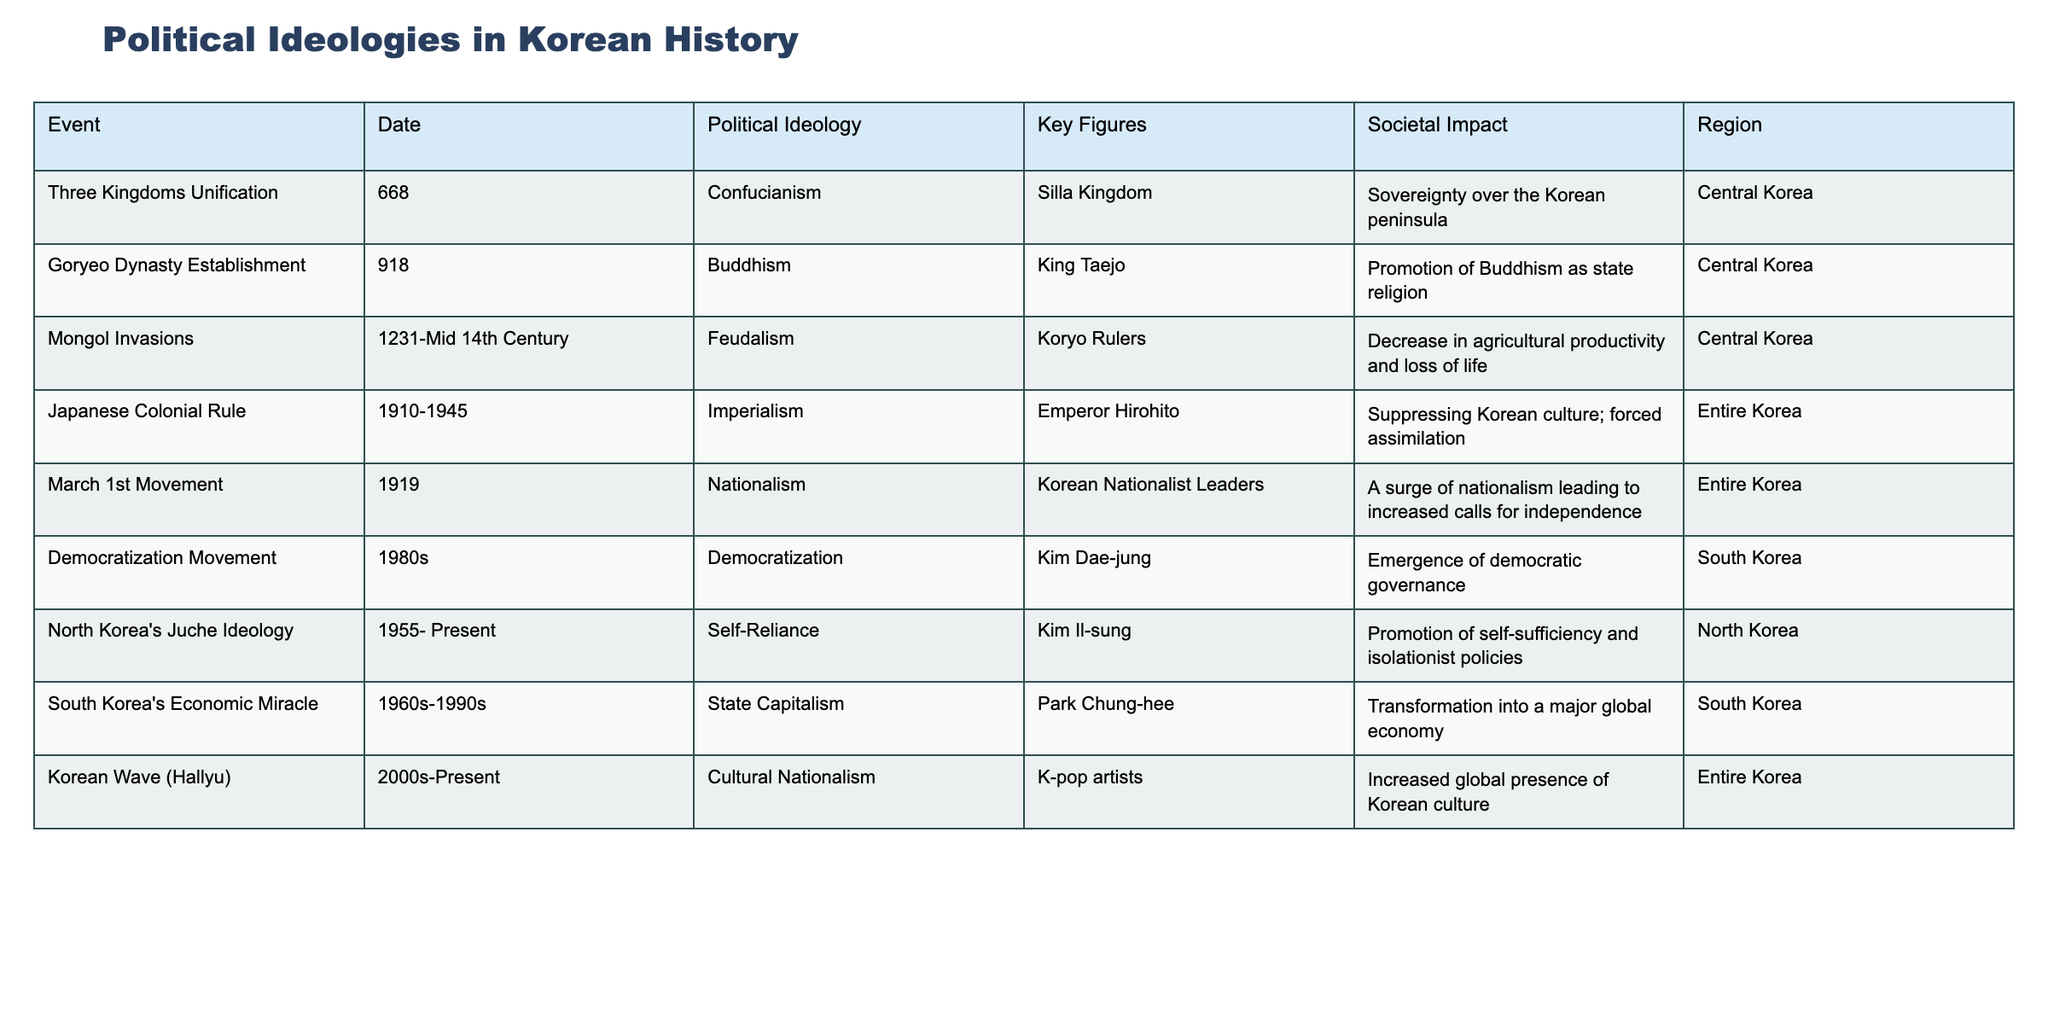What political ideology was associated with the March 1st Movement? The table indicates that the March 1st Movement is linked to Nationalism.
Answer: Nationalism Who were the key figures during Japanese Colonial Rule? According to the table, Emperor Hirohito is identified as a key figure during Japanese Colonial Rule.
Answer: Emperor Hirohito Which event marks the establishment of the Goryeo Dynasty? The table specifies that the Goryeo Dynasty was established in 918.
Answer: 918 What societal impact is associated with North Korea's Juche Ideology? The table indicates that North Korea's Juche Ideology promoted self-sufficiency and isolationist policies.
Answer: Self-sufficiency and isolationist policies How many events are associated with the region of South Korea? The table lists three events in South Korea: the Democratization Movement, South Korea's Economic Miracle, and the March 1st Movement, so there are three events.
Answer: 3 Which event occurred first: the Mongol Invasions or the establishment of the Goryeo Dynasty? The table shows that the Goryeo Dynasty was established in 918, and the Mongol Invasions began in 1231, indicating that the Goryeo Dynasty's establishment occurred first.
Answer: Goryeo Dynasty Establishment Is it true that Confucianism was a political ideology during the Three Kingdoms period? The table confirms that Confucianism is listed as the political ideology during the Three Kingdoms Unification, so the statement is true.
Answer: True What was the primary societal impact of the Korean Wave (Hallyu)? The table states that the Korean Wave (Hallyu) led to an increased global presence of Korean culture, reflecting its societal impact.
Answer: Increased global presence of Korean culture Which political ideology had the longest duration based on the events listed? Analyzing the table, North Korea's Juche Ideology has been present from 1955 to the present, giving it the longest duration compared to other political ideologies listed.
Answer: Self-Reliance (Juche Ideology) How did the societal impact of Japanese Colonial Rule compare to that of the March 1st Movement? The table shows that Japanese Colonial Rule suppressed Korean culture and enforced forced assimilation, while the March 1st Movement resulted in a surge of nationalism and calls for independence. This suggests a contrast between suppression and a push for self-determination.
Answer: Contrast: suppression vs. surge of nationalism 